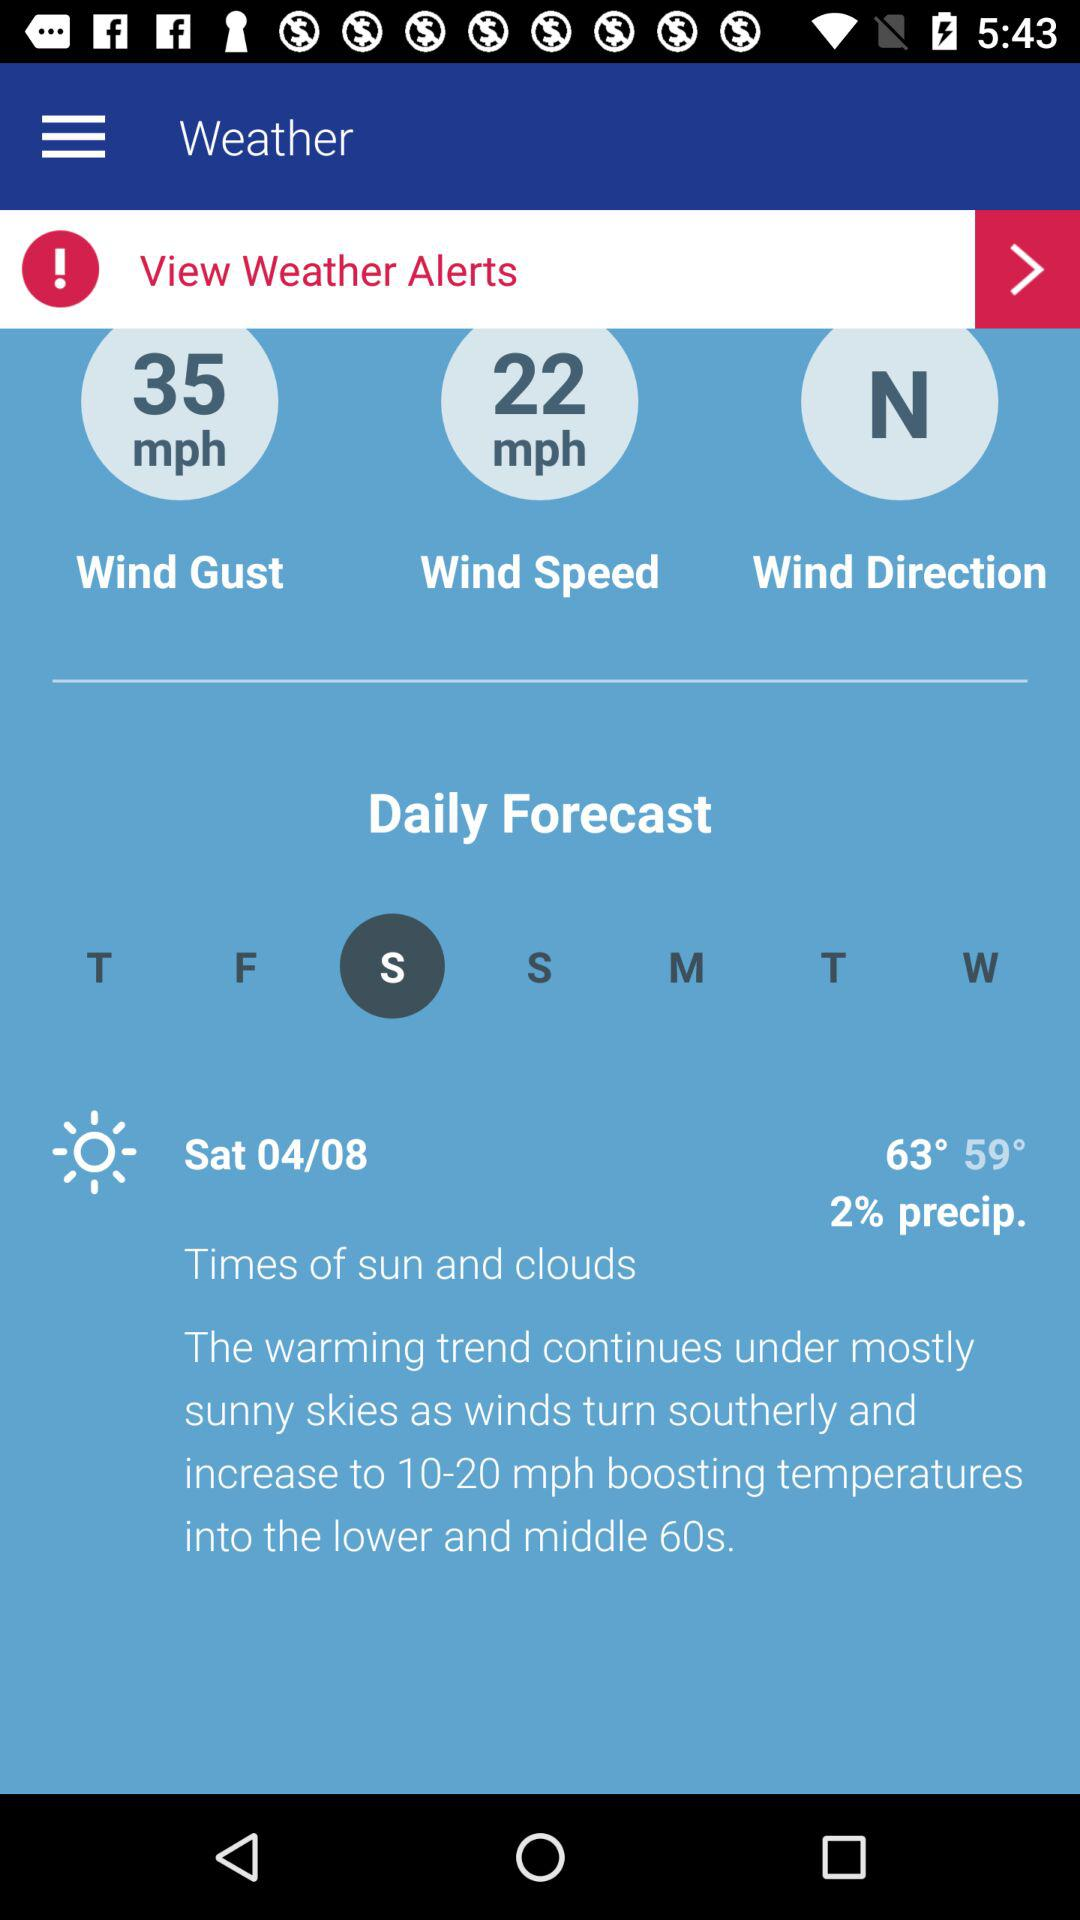What is the wind direction? The direction of the wind is north. 